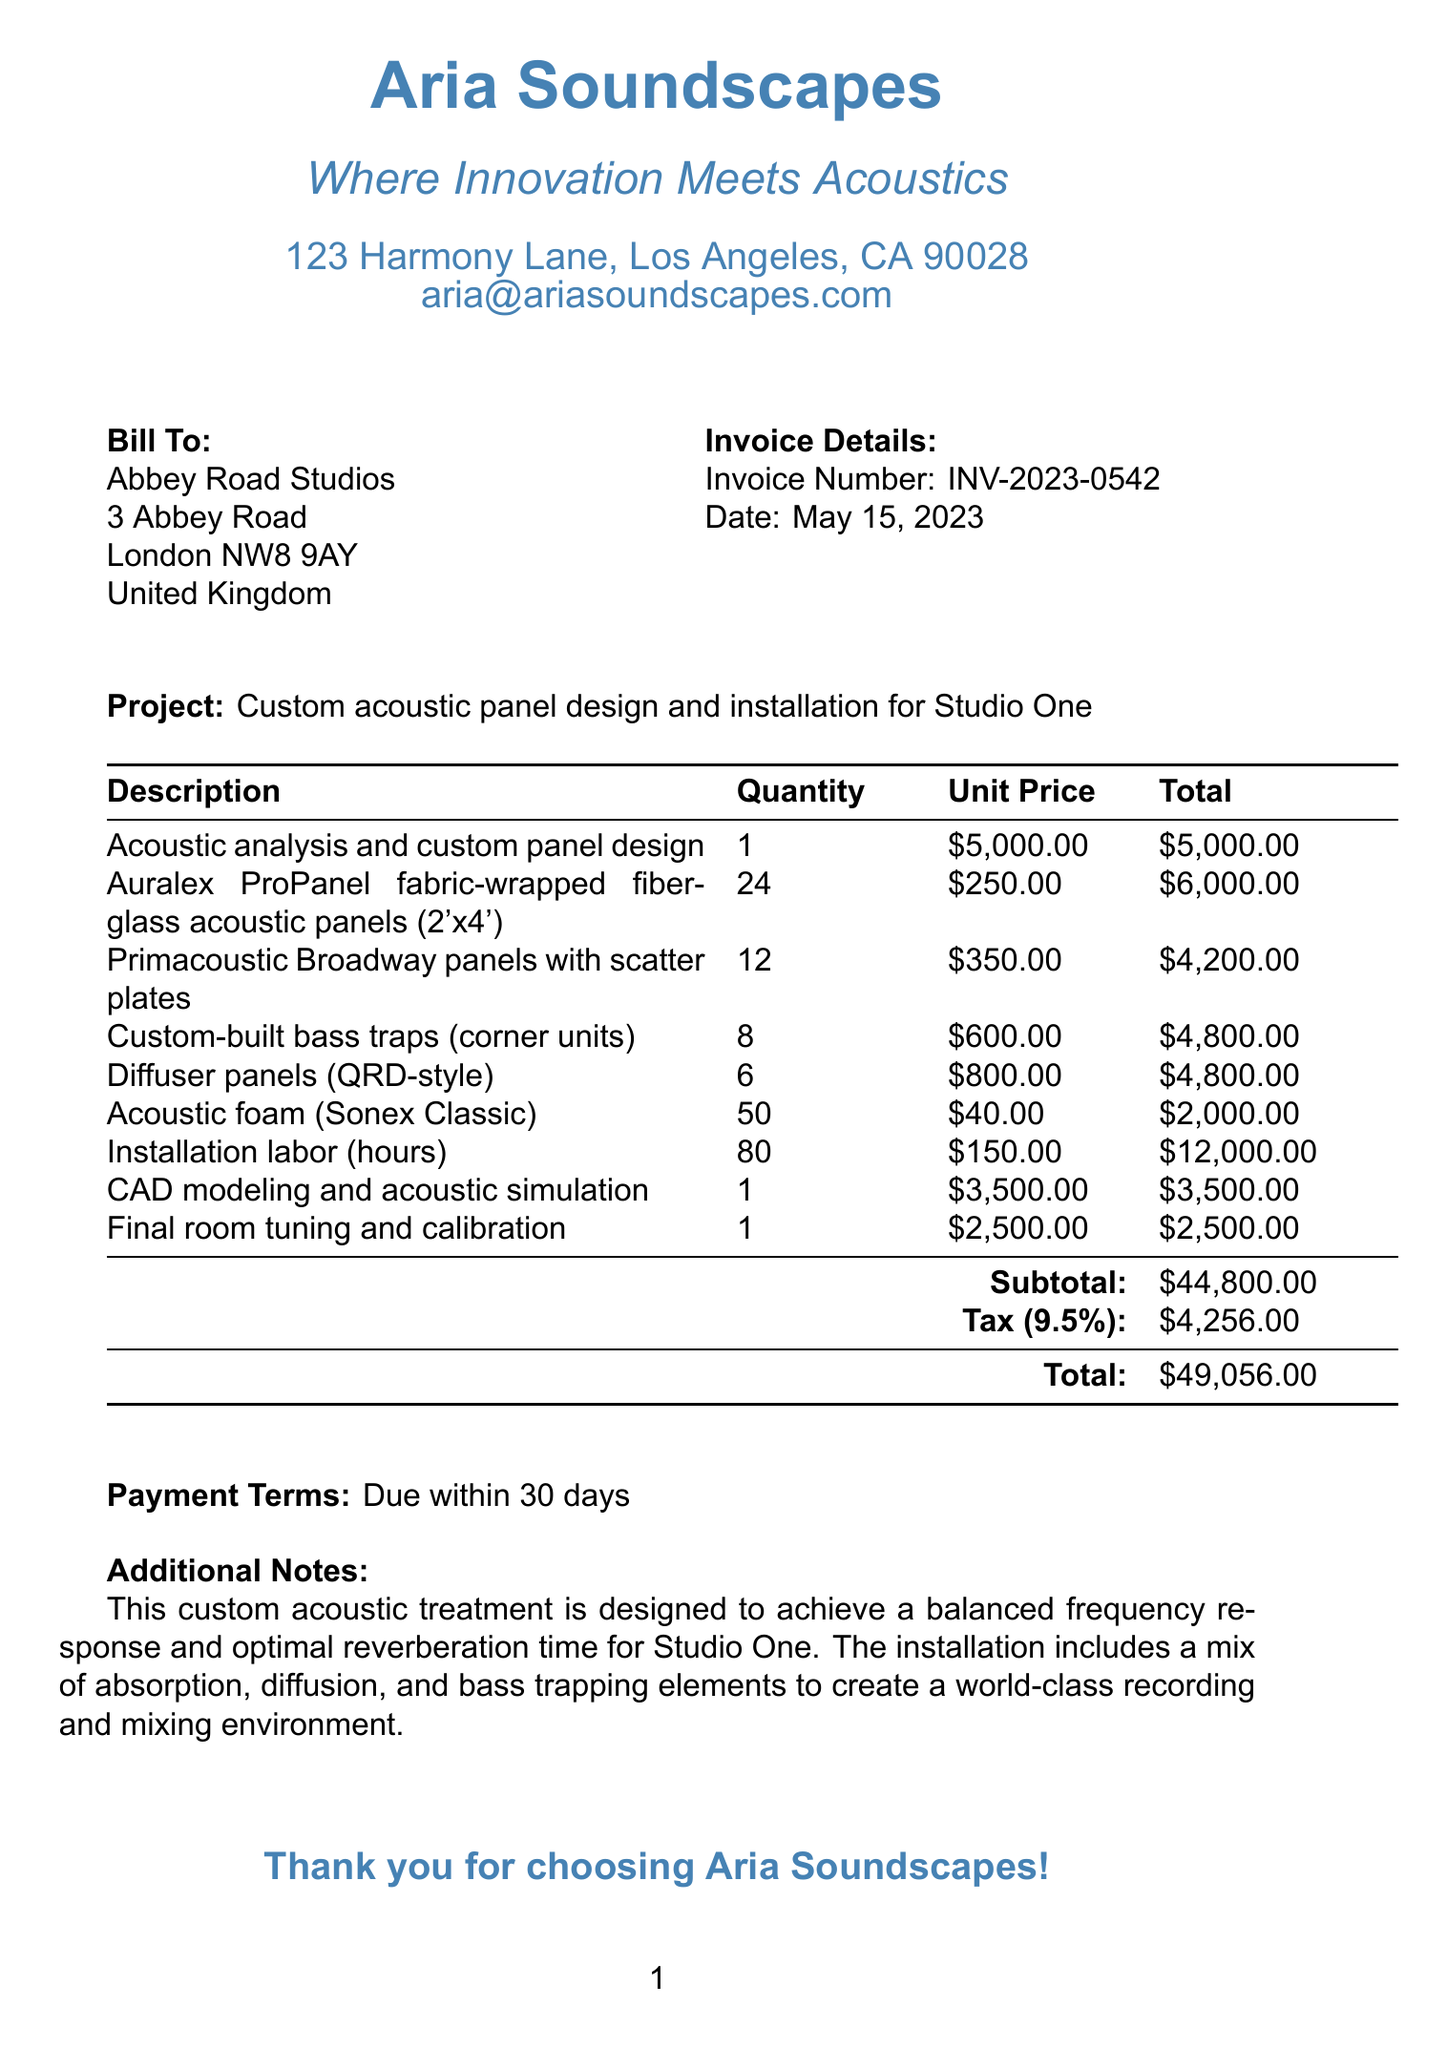What is the invoice number? The invoice number is stated at the top of the document for identification purposes.
Answer: INV-2023-0542 What is the date of the invoice? The date is specified right below the invoice number, indicating when the invoice was issued.
Answer: May 15, 2023 Who is the service provider? The service provider's details are provided in the header section of the document.
Answer: Aria Soundscapes What is the total amount due? The document sums the subtotal and tax to show the total amount owed.
Answer: $49,056.00 How many acoustic panels were custom designed? The quantity of acoustic panels is mentioned in the line items of the invoice.
Answer: 24 What additional service was provided after installation? The final step in the project description includes a specific service mentioned in the line items.
Answer: Final room tuning and calibration What is the tax rate applied to this invoice? The document explicitly states the tax rate applicable to the total amount.
Answer: 9.5% What is the payment term stated in the invoice? The payment terms are noted in a specific section of the document, describing when payment is due.
Answer: Due within 30 days What is one of the types of acoustic panels listed? The invoice lists different types of acoustic panels in the line items.
Answer: Auralex ProPanel 